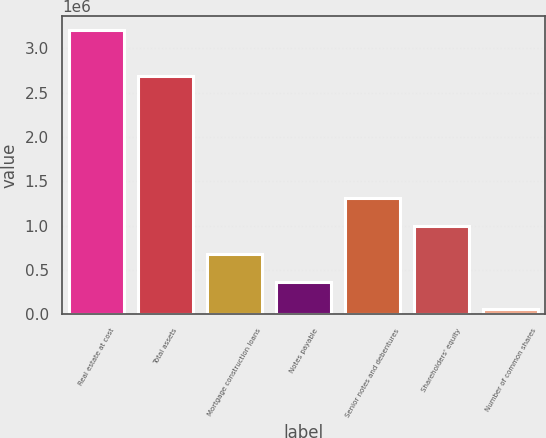Convert chart. <chart><loc_0><loc_0><loc_500><loc_500><bar_chart><fcel>Real estate at cost<fcel>Total assets<fcel>Mortgage construction loans<fcel>Notes payable<fcel>Senior notes and debentures<fcel>Shareholders' equity<fcel>Number of common shares<nl><fcel>3.20426e+06<fcel>2.68861e+06<fcel>685108<fcel>370215<fcel>1.3149e+06<fcel>1e+06<fcel>55321<nl></chart> 